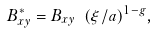Convert formula to latex. <formula><loc_0><loc_0><loc_500><loc_500>B _ { x y } ^ { * } = B _ { x y } \ ( \xi / a ) ^ { 1 - g } ,</formula> 